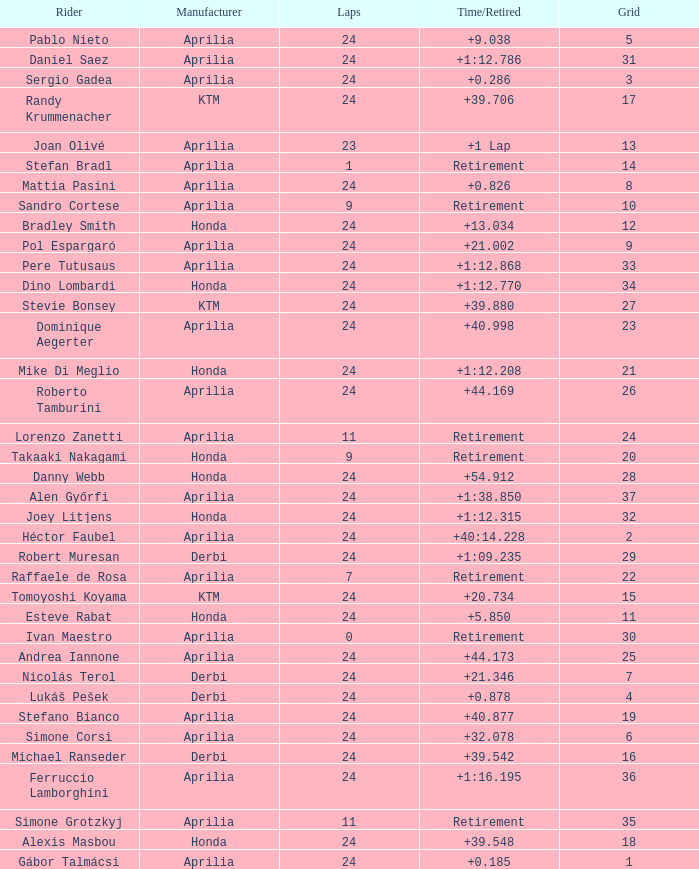Who manufactured the motorcycle that did 24 laps and 9 grids? Aprilia. 